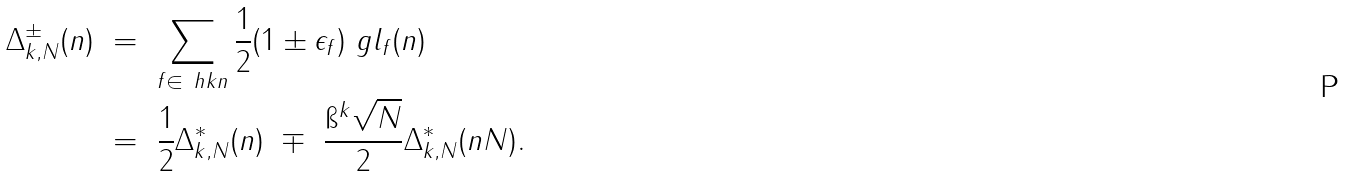Convert formula to latex. <formula><loc_0><loc_0><loc_500><loc_500>\Delta _ { k , N } ^ { \pm } ( n ) \ & = \ \sum _ { f \in \ h k n } \frac { 1 } { 2 } ( 1 \pm \epsilon _ { f } ) \ g l _ { f } ( n ) \\ \ & = \ \frac { 1 } { 2 } \Delta _ { k , N } ^ { \ast } ( n ) \ \mp \ \frac { \i ^ { k } \sqrt { N } } { 2 } \Delta _ { k , N } ^ { \ast } ( n N ) .</formula> 